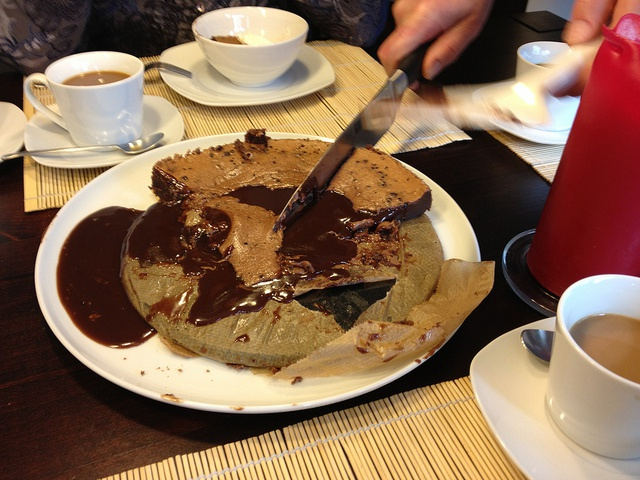Describe the objects in this image and their specific colors. I can see dining table in gray, black, tan, olive, and beige tones, cake in gray, olive, black, maroon, and tan tones, bottle in gray, maroon, brown, and black tones, cup in gray, darkgray, lightblue, and tan tones, and cup in gray, lightgray, tan, and darkgray tones in this image. 